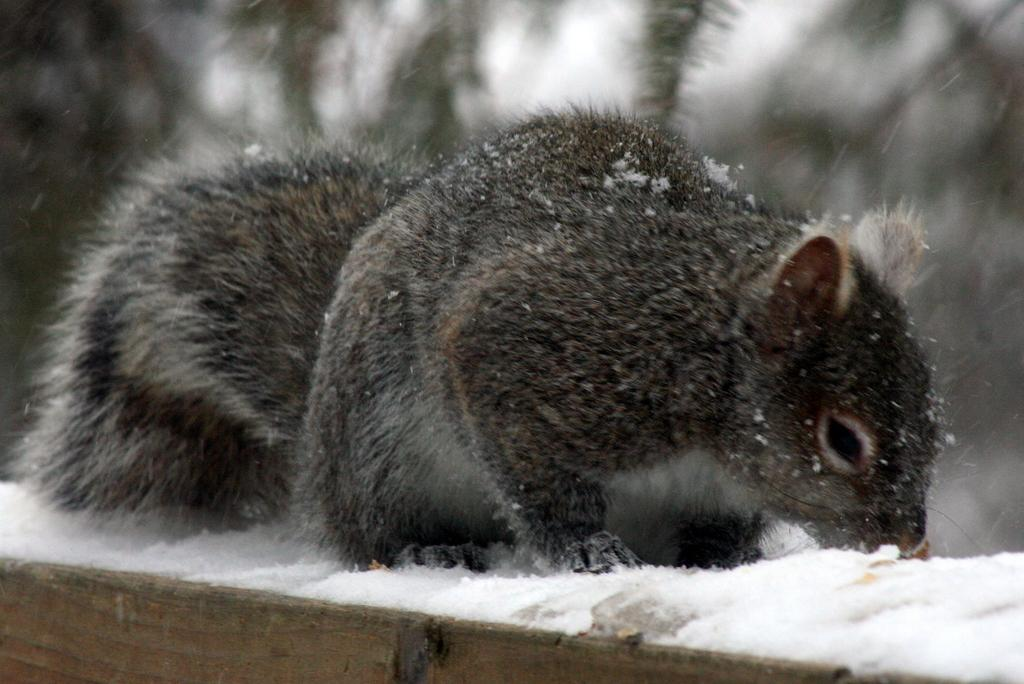What type of animal is in the image? There is a black squirrel in the image. What is the squirrel standing on? The squirrel is standing on the snow. What can be seen in the background of the image? There are trees and the sky visible in the background of the image. What is located at the bottom of the image? There is a wooden bench at the bottom of the image. What type of approval is the squirrel seeking in the image? The image does not depict the squirrel seeking any type of approval; it is simply standing on the snow. 